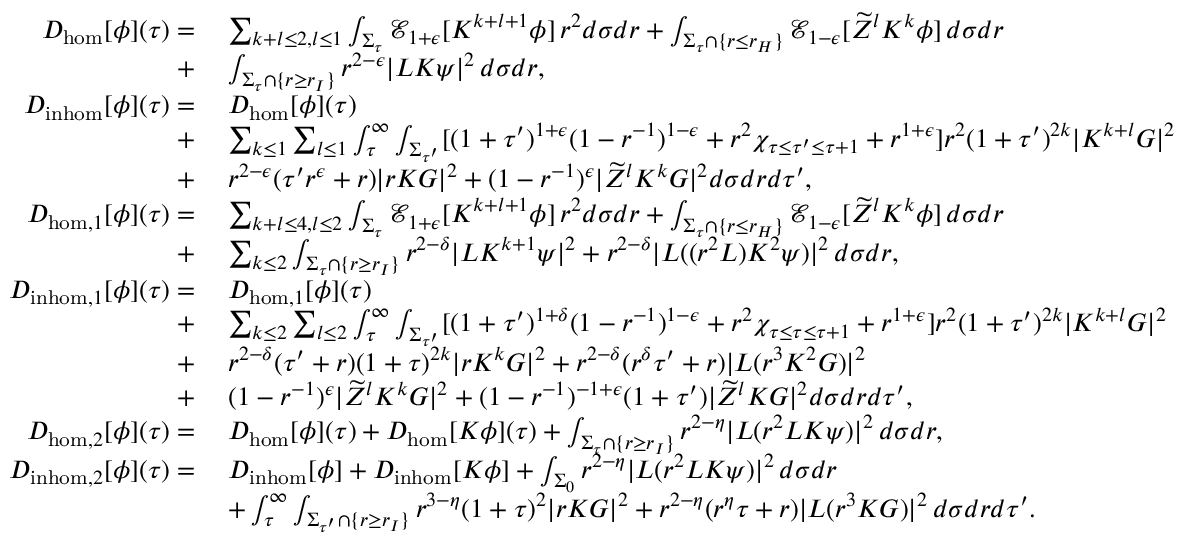Convert formula to latex. <formula><loc_0><loc_0><loc_500><loc_500>\begin{array} { r l } { D _ { h o m } [ \phi ] ( \tau ) = } & { \, \sum _ { k + l \leq 2 , l \leq 1 } \int _ { \Sigma _ { \tau } } \mathcal { E } _ { 1 + \epsilon } [ K ^ { k + l + 1 } \phi ] \, r ^ { 2 } d \sigma d r + \int _ { \Sigma _ { \tau } \cap \{ r \leq r _ { H } \} } \mathcal { E } _ { 1 - \epsilon } [ \widetilde { Z } ^ { l } K ^ { k } \phi ] \, d \sigma d r } \\ { + } & { \, \int _ { \Sigma _ { \tau } \cap \{ r \geq r _ { I } \} } r ^ { 2 - \epsilon } | L K \psi | ^ { 2 } \, d \sigma d r , } \\ { D _ { i n h o m } [ \phi ] ( \tau ) = } & { \, D _ { h o m } [ \phi ] ( \tau ) } \\ { + } & { \, \sum _ { k \leq 1 } \sum _ { l \leq 1 } \int _ { \tau } ^ { \infty } \int _ { \Sigma _ { \tau ^ { \prime } } } [ ( 1 + \tau ^ { \prime } ) ^ { 1 + \epsilon } ( 1 - r ^ { - 1 } ) ^ { 1 - \epsilon } + r ^ { 2 } \chi _ { \tau \leq \tau ^ { \prime } \leq \tau + 1 } + r ^ { 1 + \epsilon } ] r ^ { 2 } ( 1 + \tau ^ { \prime } ) ^ { 2 k } | K ^ { k + l } G | ^ { 2 } } \\ { + } & { \, r ^ { 2 - \epsilon } ( \tau ^ { \prime } r ^ { \epsilon } + r ) | r K G | ^ { 2 } + ( 1 - r ^ { - 1 } ) ^ { \epsilon } | \widetilde { Z } ^ { l } K ^ { k } G | ^ { 2 } d \sigma d r d \tau ^ { \prime } , } \\ { D _ { h o m , 1 } [ \phi ] ( \tau ) = } & { \, \sum _ { k + l \leq 4 , l \leq 2 } \int _ { \Sigma _ { \tau } } \mathcal { E } _ { 1 + \epsilon } [ K ^ { k + l + 1 } \phi ] \, r ^ { 2 } d \sigma d r + \int _ { \Sigma _ { \tau } \cap \{ r \leq r _ { H } \} } \mathcal { E } _ { 1 - \epsilon } [ \widetilde { Z } ^ { l } K ^ { k } \phi ] \, d \sigma d r } \\ { + } & { \, \sum _ { k \leq 2 } \int _ { \Sigma _ { \tau } \cap \{ r \geq r _ { I } \} } r ^ { 2 - \delta } | L K ^ { k + 1 } \psi | ^ { 2 } + r ^ { 2 - \delta } | L ( ( r ^ { 2 } L ) K ^ { 2 } \psi ) | ^ { 2 } \, d \sigma d r , } \\ { D _ { i n h o m , 1 } [ \phi ] ( \tau ) = } & { \, D _ { h o m , 1 } [ \phi ] ( \tau ) } \\ { + } & { \, \sum _ { k \leq 2 } \sum _ { l \leq 2 } \int _ { \tau } ^ { \infty } \int _ { \Sigma _ { \tau ^ { \prime } } } [ ( 1 + \tau ^ { \prime } ) ^ { 1 + \delta } ( 1 - r ^ { - 1 } ) ^ { 1 - \epsilon } + r ^ { 2 } \chi _ { \tau \leq \tau \leq \tau + 1 } + r ^ { 1 + \epsilon } ] r ^ { 2 } ( 1 + \tau ^ { \prime } ) ^ { 2 k } | K ^ { k + l } G | ^ { 2 } } \\ { + } & { \, r ^ { 2 - \delta } ( \tau ^ { \prime } + r ) ( 1 + \tau ) ^ { 2 k } | r K ^ { k } G | ^ { 2 } + r ^ { 2 - \delta } ( r ^ { \delta } \tau ^ { \prime } + r ) | L ( r ^ { 3 } K ^ { 2 } G ) | ^ { 2 } } \\ { + } & { \, ( 1 - r ^ { - 1 } ) ^ { \epsilon } | \widetilde { Z } ^ { l } K ^ { k } G | ^ { 2 } + ( 1 - r ^ { - 1 } ) ^ { - 1 + \epsilon } ( 1 + \tau ^ { \prime } ) | \widetilde { Z } ^ { l } K G | ^ { 2 } d \sigma d r d \tau ^ { \prime } , } \\ { D _ { h o m , 2 } [ \phi ] ( \tau ) = } & { \, D _ { h o m } [ \phi ] ( \tau ) + D _ { h o m } [ K \phi ] ( \tau ) + \int _ { \Sigma _ { \tau } \cap \{ r \geq r _ { I } \} } r ^ { 2 - \eta } | L ( r ^ { 2 } L K \psi ) | ^ { 2 } \, d \sigma d r , } \\ { D _ { i n h o m , 2 } [ \phi ] ( \tau ) = } & { \, D _ { i n h o m } [ \phi ] + D _ { i n h o m } [ K \phi ] + \int _ { \Sigma _ { 0 } } r ^ { 2 - \eta } | L ( r ^ { 2 } L K \psi ) | ^ { 2 } \, d \sigma d r } \\ & { \, + \int _ { \tau } ^ { \infty } \int _ { \Sigma _ { \tau ^ { \prime } } \cap \{ r \geq r _ { I } \} } r ^ { 3 - \eta } ( 1 + \tau ) ^ { 2 } | r K G | ^ { 2 } + r ^ { 2 - \eta } ( r ^ { \eta } \tau + r ) | L ( r ^ { 3 } K G ) | ^ { 2 } \, d \sigma d r d \tau ^ { \prime } . } \end{array}</formula> 